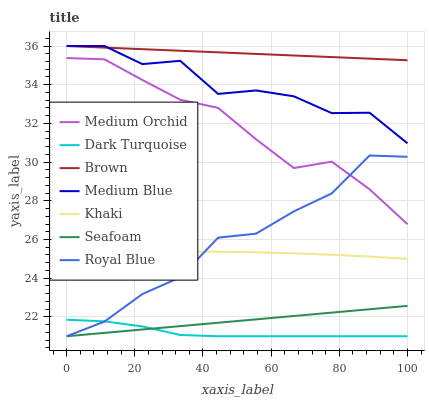Does Dark Turquoise have the minimum area under the curve?
Answer yes or no. Yes. Does Brown have the maximum area under the curve?
Answer yes or no. Yes. Does Khaki have the minimum area under the curve?
Answer yes or no. No. Does Khaki have the maximum area under the curve?
Answer yes or no. No. Is Seafoam the smoothest?
Answer yes or no. Yes. Is Medium Blue the roughest?
Answer yes or no. Yes. Is Khaki the smoothest?
Answer yes or no. No. Is Khaki the roughest?
Answer yes or no. No. Does Dark Turquoise have the lowest value?
Answer yes or no. Yes. Does Khaki have the lowest value?
Answer yes or no. No. Does Medium Blue have the highest value?
Answer yes or no. Yes. Does Khaki have the highest value?
Answer yes or no. No. Is Seafoam less than Brown?
Answer yes or no. Yes. Is Medium Orchid greater than Seafoam?
Answer yes or no. Yes. Does Dark Turquoise intersect Seafoam?
Answer yes or no. Yes. Is Dark Turquoise less than Seafoam?
Answer yes or no. No. Is Dark Turquoise greater than Seafoam?
Answer yes or no. No. Does Seafoam intersect Brown?
Answer yes or no. No. 